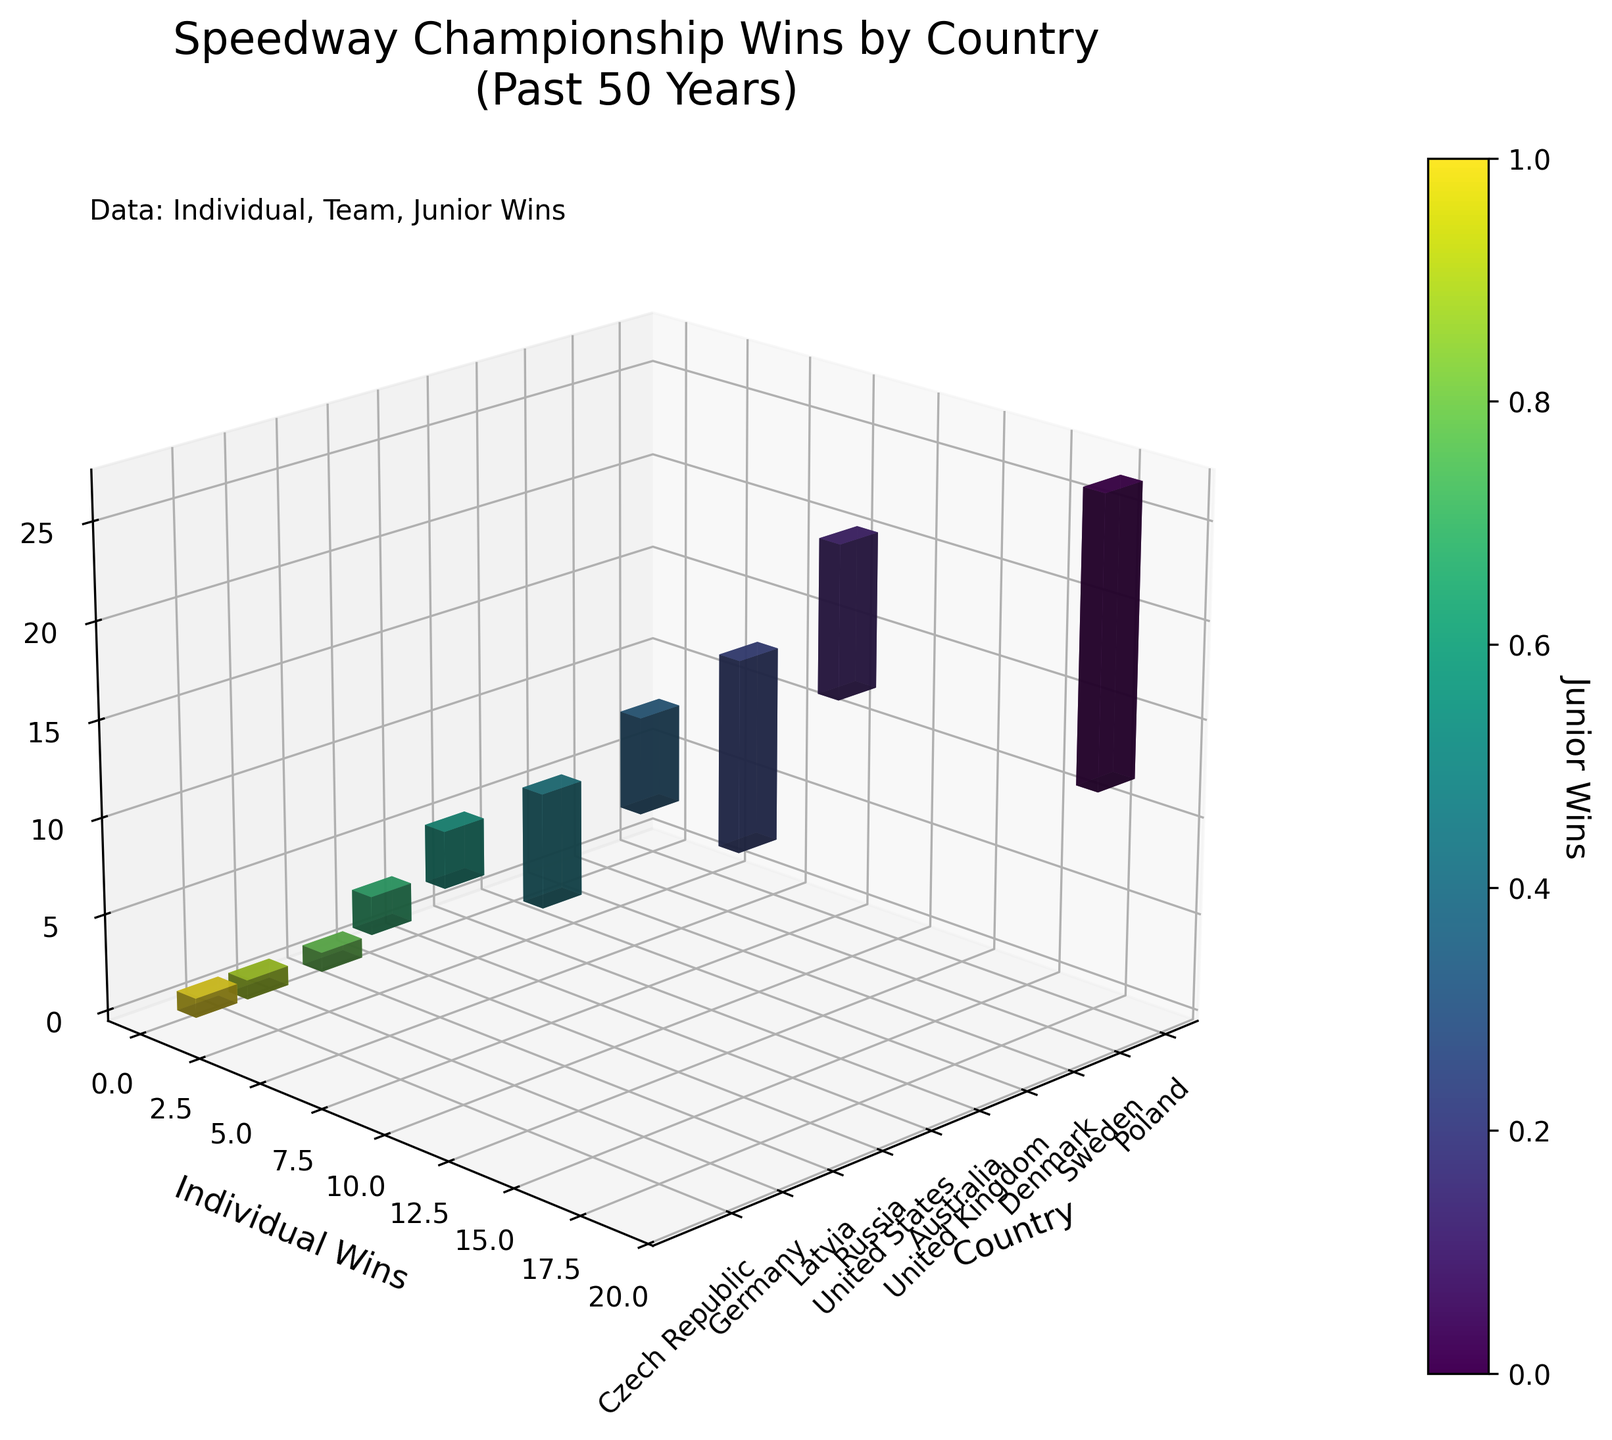What's the title of the figure? The title is written at the top of the figure to give a quick overview of the data presented. In this case, it is "Speedway Championship Wins by Country\n(Past 50 Years)".
Answer: Speedway Championship Wins by Country (Past 50 Years) What does the color bar represent? The color bar is labeled next to the figure to indicate what it represents. Here, it is titled "Junior Wins," which shows the number of junior championship wins using different colors.
Answer: Junior Wins How many individual wins does the United Kingdom have? To find the number of individual wins, locate the bar for the United Kingdom on the x-axis and read the y-axis value corresponding to it.
Answer: 6 Which country has the most team wins? To find this, compare the heights of the bars along the z-axis for each country. Sweden has the highest bar, indicating the most team wins.
Answer: Sweden How many junior wins do Latvia and Germany have combined? Look at the color bar for each country to find their junior wins. Latvia has 1 junior win, and Germany has 1 as well. Adding these together gives you the total.
Answer: 2 Which country has more team wins: Denmark or Australia? Compare the heights of the bars along the z-axis for Denmark and Australia. Denmark has 6 team wins, and Australia has 3. Therefore, Denmark has more team wins.
Answer: Denmark What is the sum of junior wins for Poland, Sweden, and Denmark? Look at the color bar to find the junior wins for each country. Poland has 15, Sweden has 8, and Denmark has 10. Adding these together gives 15 + 8 + 10 = 33.
Answer: 33 How does the number of individual wins for Poland compare to the total number of individual wins for Latvia and the United States combined? Poland has 18 individual wins. Latvia has 1, and the United States has 2. Adding Latvia's and the United States' wins gives 1 + 2 = 3. Therefore, Poland has more individual wins.
Answer: Poland has more What is the ratio of individual wins to team wins for Sweden? To find the ratio, divide the number of individual wins by the number of team wins for Sweden. Sweden has 10 individual wins and 14 team wins, so the ratio is 10/14 which simplifies to 5/7.
Answer: 5:7 If you arranged all countries by combined wins (individual, team, junior) in descending order, which country would be third? First, sum the wins for each category per country. For Denmark: 8 (individual) + 6 (team) + 10 (junior) = 24. Then order all countries by this total in descending order. Third place is Sweden with a combined total of 32 wins (10 + 14 + 8).
Answer: Sweden 